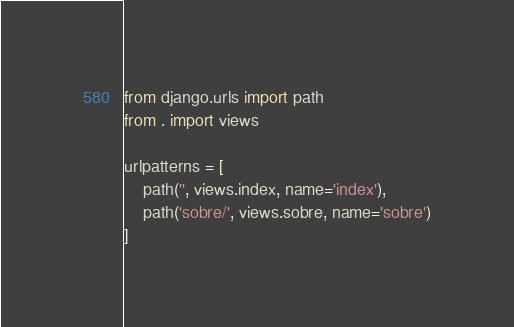<code> <loc_0><loc_0><loc_500><loc_500><_Python_>from django.urls import path
from . import views

urlpatterns = [
    path('', views.index, name='index'),
    path('sobre/', views.sobre, name='sobre')
]</code> 